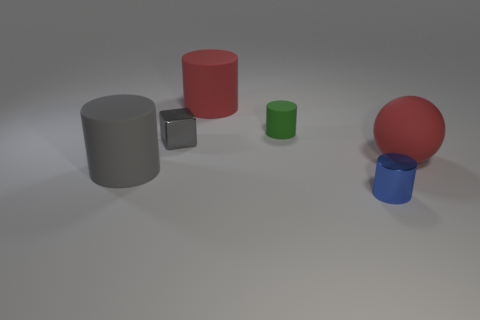Is the number of big gray objects to the right of the gray cube less than the number of blue spheres?
Ensure brevity in your answer.  No. There is a big matte cylinder that is behind the big gray cylinder; what color is it?
Provide a succinct answer. Red. The large gray rubber thing has what shape?
Your answer should be compact. Cylinder. There is a large matte object that is on the right side of the large matte thing behind the red sphere; are there any gray metal cubes in front of it?
Offer a very short reply. No. There is a tiny cylinder in front of the large cylinder that is left of the large cylinder that is on the right side of the large gray rubber cylinder; what color is it?
Your answer should be compact. Blue. What material is the large red thing that is the same shape as the small green rubber thing?
Your response must be concise. Rubber. How big is the red object left of the big red rubber object that is to the right of the small rubber thing?
Keep it short and to the point. Large. What is the tiny thing right of the green thing made of?
Offer a very short reply. Metal. What size is the gray cylinder that is made of the same material as the red sphere?
Offer a terse response. Large. What number of other large gray matte things have the same shape as the large gray rubber object?
Offer a very short reply. 0. 